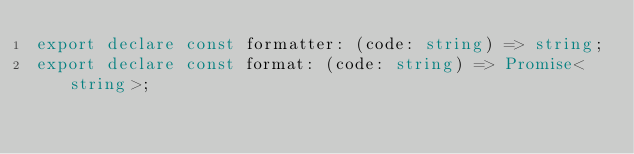Convert code to text. <code><loc_0><loc_0><loc_500><loc_500><_TypeScript_>export declare const formatter: (code: string) => string;
export declare const format: (code: string) => Promise<string>;
</code> 